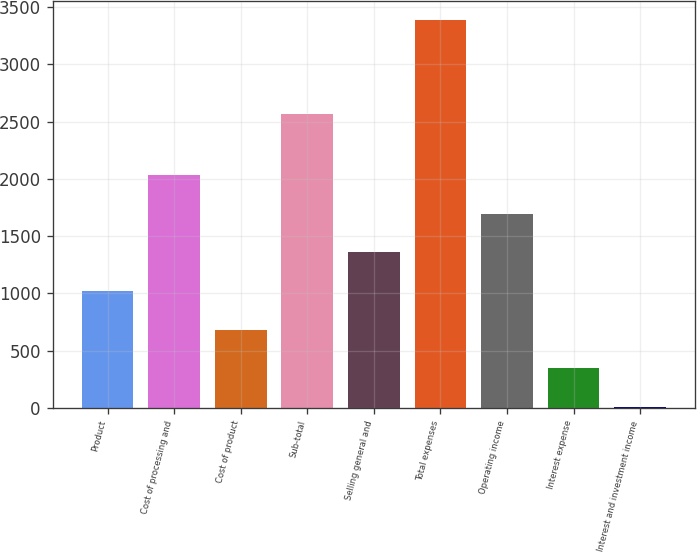<chart> <loc_0><loc_0><loc_500><loc_500><bar_chart><fcel>Product<fcel>Cost of processing and<fcel>Cost of product<fcel>Sub-total<fcel>Selling general and<fcel>Total expenses<fcel>Operating income<fcel>Interest expense<fcel>Interest and investment income<nl><fcel>1021.3<fcel>2035.6<fcel>683.2<fcel>2564<fcel>1359.4<fcel>3388<fcel>1697.5<fcel>345.1<fcel>7<nl></chart> 